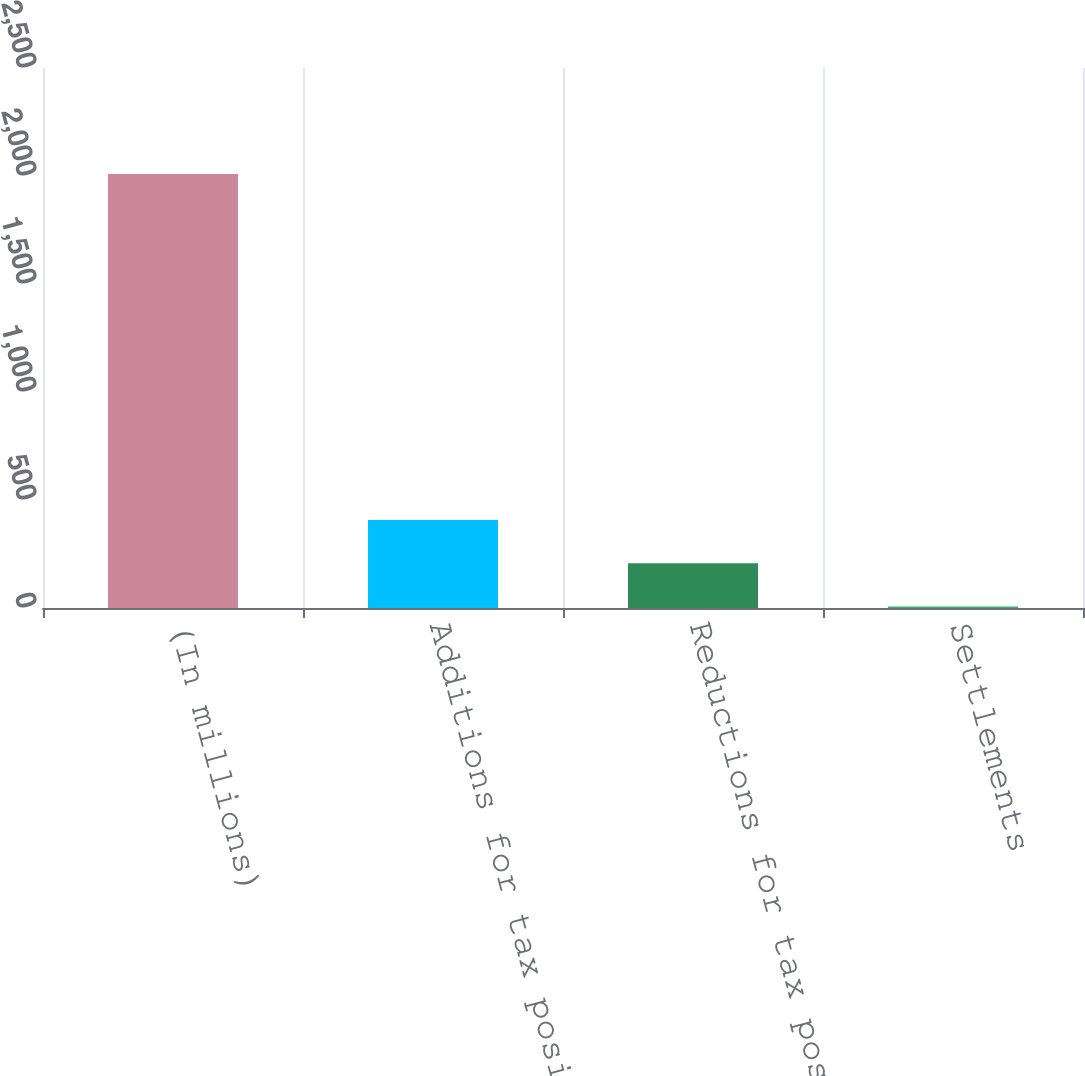Convert chart to OTSL. <chart><loc_0><loc_0><loc_500><loc_500><bar_chart><fcel>(In millions)<fcel>Additions for tax positions of<fcel>Reductions for tax positions<fcel>Settlements<nl><fcel>2009<fcel>407.4<fcel>207.2<fcel>7<nl></chart> 